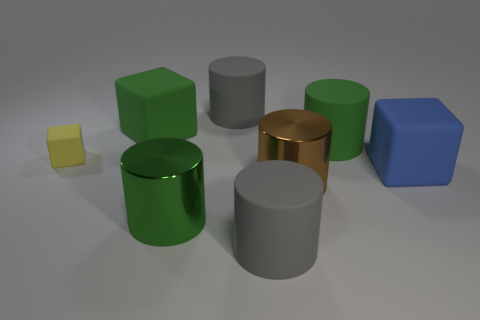The other metal object that is the same size as the green shiny thing is what color?
Your answer should be compact. Brown. The small cube has what color?
Provide a succinct answer. Yellow. There is a big green thing that is in front of the big blue object; what material is it?
Give a very brief answer. Metal. What size is the green metal thing that is the same shape as the brown thing?
Provide a short and direct response. Large. Are there fewer large brown shiny cylinders to the right of the blue object than tiny brown rubber things?
Give a very brief answer. No. Are any big gray rubber cubes visible?
Your answer should be compact. No. The other large metallic object that is the same shape as the brown thing is what color?
Provide a short and direct response. Green. Does the green metal cylinder have the same size as the green cube?
Make the answer very short. Yes. The yellow thing that is made of the same material as the green cube is what shape?
Provide a succinct answer. Cube. What number of other things are there of the same shape as the yellow rubber object?
Provide a succinct answer. 2. 